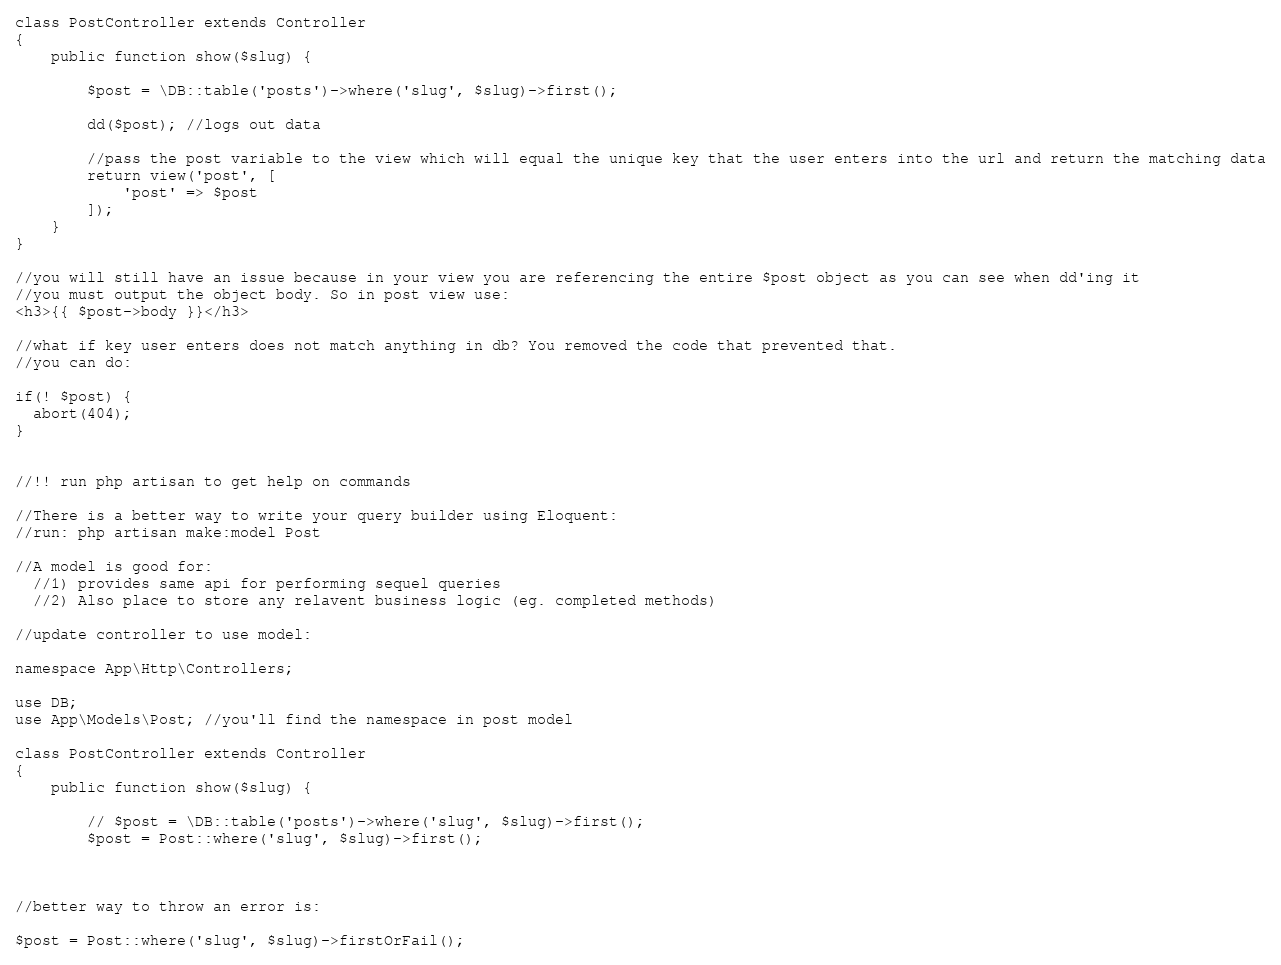Convert code to text. <code><loc_0><loc_0><loc_500><loc_500><_PHP_>
class PostController extends Controller
{
    public function show($slug) {

        $post = \DB::table('posts')->where('slug', $slug)->first();

        dd($post); //logs out data

        //pass the post variable to the view which will equal the unique key that the user enters into the url and return the matching data
        return view('post', [
            'post' => $post
        ]);
    }
}

//you will still have an issue because in your view you are referencing the entire $post object as you can see when dd'ing it
//you must output the object body. So in post view use:
<h3>{{ $post->body }}</h3>

//what if key user enters does not match anything in db? You removed the code that prevented that.
//you can do:

if(! $post) {
  abort(404);
}


//!! run php artisan to get help on commands

//There is a better way to write your query builder using Eloquent:
//run: php artisan make:model Post

//A model is good for:
  //1) provides same api for performing sequel queries 
  //2) Also place to store any relavent business logic (eg. completed methods)

//update controller to use model:

namespace App\Http\Controllers;

use DB;
use App\Models\Post; //you'll find the namespace in post model

class PostController extends Controller
{
    public function show($slug) {

        // $post = \DB::table('posts')->where('slug', $slug)->first();
        $post = Post::where('slug', $slug)->first();



//better way to throw an error is:

$post = Post::where('slug', $slug)->firstOrFail();</code> 